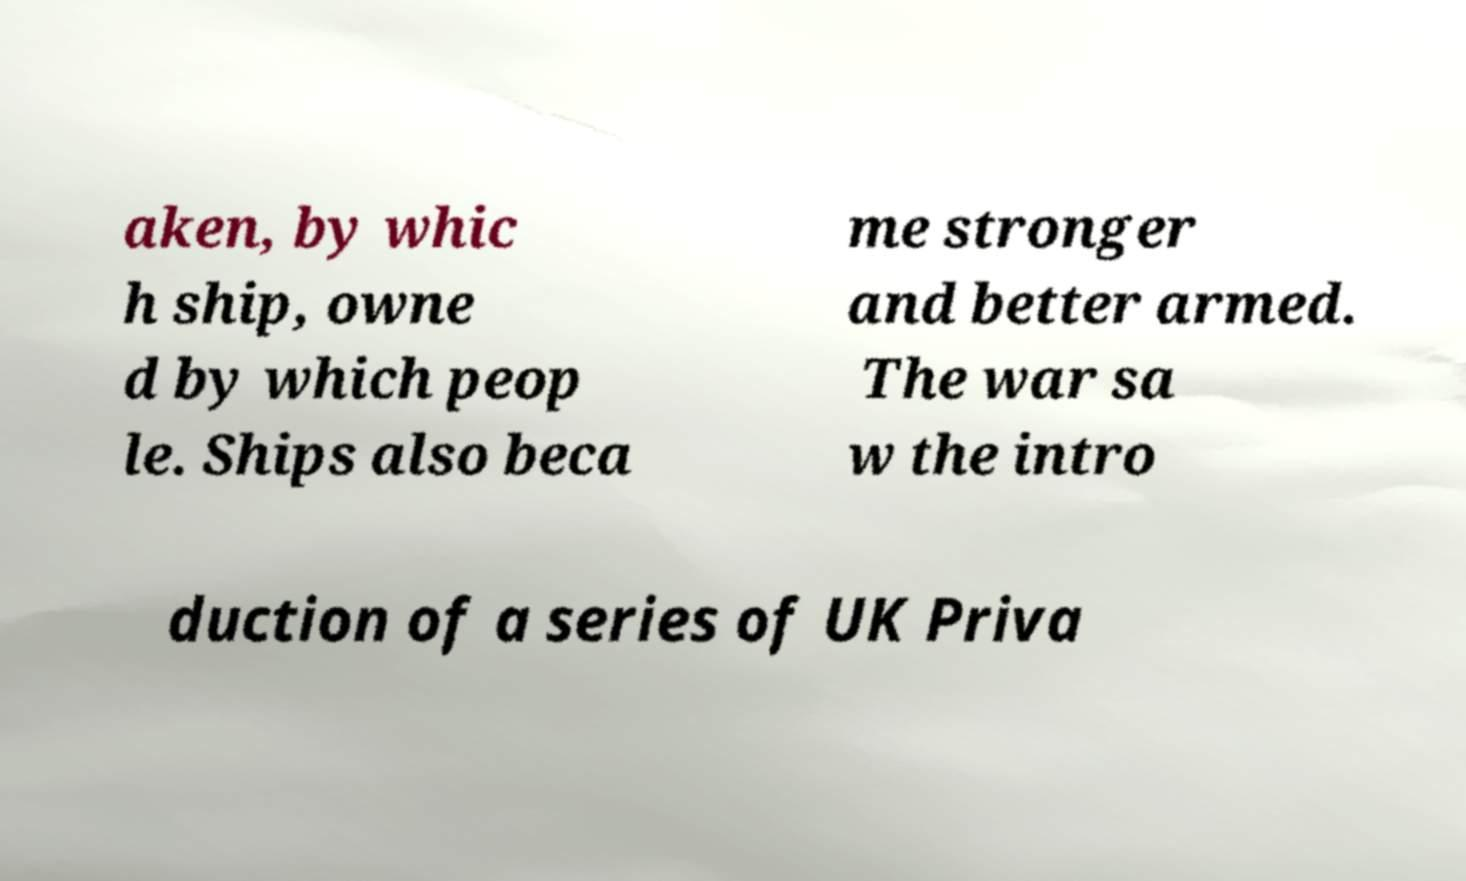What messages or text are displayed in this image? I need them in a readable, typed format. aken, by whic h ship, owne d by which peop le. Ships also beca me stronger and better armed. The war sa w the intro duction of a series of UK Priva 